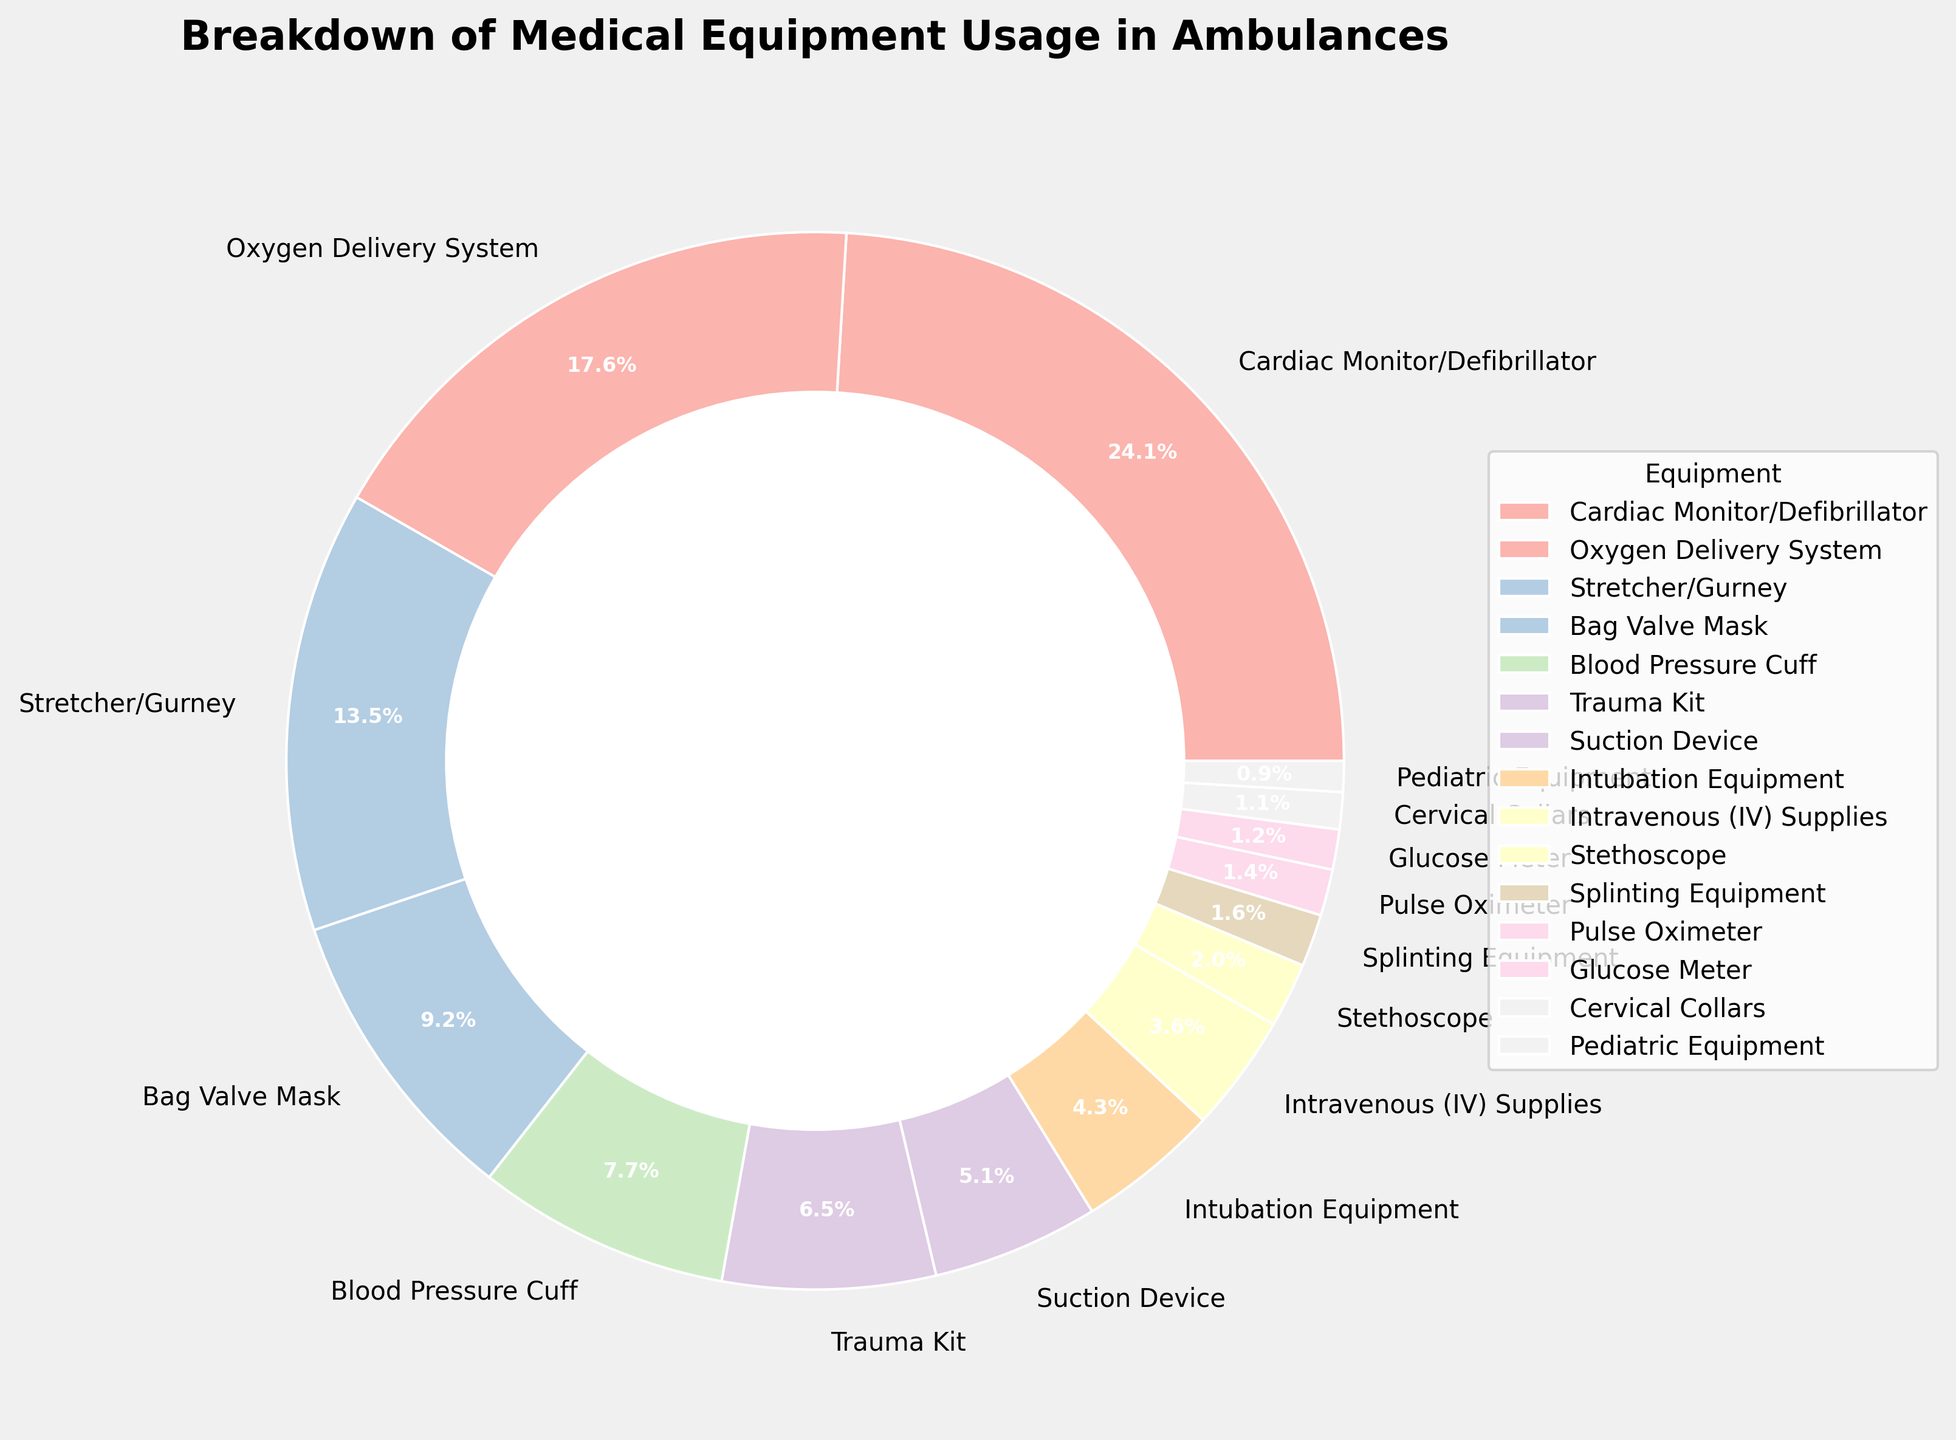What equipment has the highest usage percentage? By looking at the pie chart and identifying the largest segment, we can see that the Cardiac Monitor/Defibrillator has the highest usage percentage at 25.5%.
Answer: Cardiac Monitor/Defibrillator What equipment is used more, the Stretcher/Gurney or the Blood Pressure Cuff? Comparing the segments for Stretcher/Gurney and Blood Pressure Cuff, the Stretcher/Gurney has a usage percentage of 14.3%, which is higher than the Blood Pressure Cuff's 8.2%.
Answer: Stretcher/Gurney How much more is the Oxygen Delivery System used compared to the Trauma Kit? The Oxygen Delivery System has a usage percentage of 18.7%, while the Trauma Kit has 6.9%. The difference is calculated as 18.7% - 6.9% = 11.8%.
Answer: 11.8% Which equipment usage percentages combined make up over 50% of total usage? Adding the highest usage percentages until they exceed 50%, we have Cardiac Monitor/Defibrillator (25.5%) + Oxygen Delivery System (18.7%) + Stretcher/Gurney (14.3%) = 58.5%. These three combined cross the 50% mark.
Answer: Cardiac Monitor/Defibrillator, Oxygen Delivery System, Stretcher/Gurney What is the total combined usage percentage of the Bag Valve Mask, Blood Pressure Cuff, and Trauma Kit? Summing up these three equipment percentages: Bag Valve Mask (9.8%) + Blood Pressure Cuff (8.2%) + Trauma Kit (6.9%) = 24.9%.
Answer: 24.9% What is the least used equipment in ambulances based on the chart? Identifying the smallest segment in the pie chart, the Pediatric Equipment has the smallest usage percentage of 1.0%.
Answer: Pediatric Equipment Is the usage percentage of the Suction Device greater than or less than the Intubation Equipment? By comparing the two segments, the Suction Device has a higher percentage of 5.4% compared to the Intubation Equipment's 4.6%.
Answer: Greater What percentage of the equipment usage does the Splinting Equipment and the Glucose Meter make up together? Adding the percentages for Splinting Equipment (1.7%) and Glucose Meter (1.3%), we get 1.7% + 1.3% = 3%.
Answer: 3% Which equipment's usage is closest to the average usage percentage of all listed equipment? First calculate the average: (25.5 + 18.7 + 14.3 + 9.8 + 8.2 + 6.9 + 5.4 + 4.6 + 3.8 + 2.1 + 1.7 + 1.5 + 1.3 + 1.2 + 1.0) / 15 = 7.32%. Intubation Equipment, with 4.6%, is the closest.
Answer: Intubation Equipment How many pieces of equipment have a usage percentage less than 5%? Counting segments in the pie chart with usage percentages below 5%, we have: Intubation Equipment (4.6%), Intravenous (IV) Supplies (3.8%), Stethoscope (2.1%), Splinting Equipment (1.7%), Pulse Oximeter (1.5%), Glucose Meter (1.3%), Cervical Collars (1.2%), Pediatric Equipment (1.0%) totaling 8 segments.
Answer: 8 